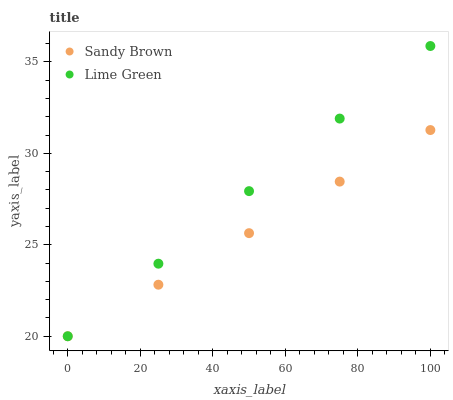Does Sandy Brown have the minimum area under the curve?
Answer yes or no. Yes. Does Lime Green have the maximum area under the curve?
Answer yes or no. Yes. Does Sandy Brown have the maximum area under the curve?
Answer yes or no. No. Is Sandy Brown the smoothest?
Answer yes or no. Yes. Is Lime Green the roughest?
Answer yes or no. Yes. Is Sandy Brown the roughest?
Answer yes or no. No. Does Lime Green have the lowest value?
Answer yes or no. Yes. Does Lime Green have the highest value?
Answer yes or no. Yes. Does Sandy Brown have the highest value?
Answer yes or no. No. Does Lime Green intersect Sandy Brown?
Answer yes or no. Yes. Is Lime Green less than Sandy Brown?
Answer yes or no. No. Is Lime Green greater than Sandy Brown?
Answer yes or no. No. 